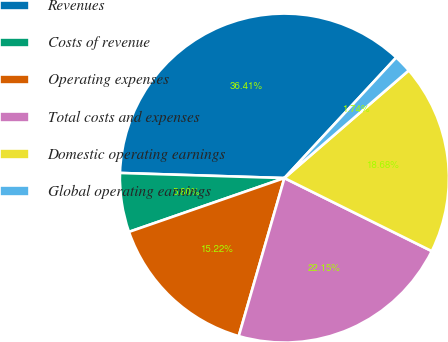Convert chart. <chart><loc_0><loc_0><loc_500><loc_500><pie_chart><fcel>Revenues<fcel>Costs of revenue<fcel>Operating expenses<fcel>Total costs and expenses<fcel>Domestic operating earnings<fcel>Global operating earnings<nl><fcel>36.41%<fcel>5.8%<fcel>15.22%<fcel>22.15%<fcel>18.68%<fcel>1.74%<nl></chart> 